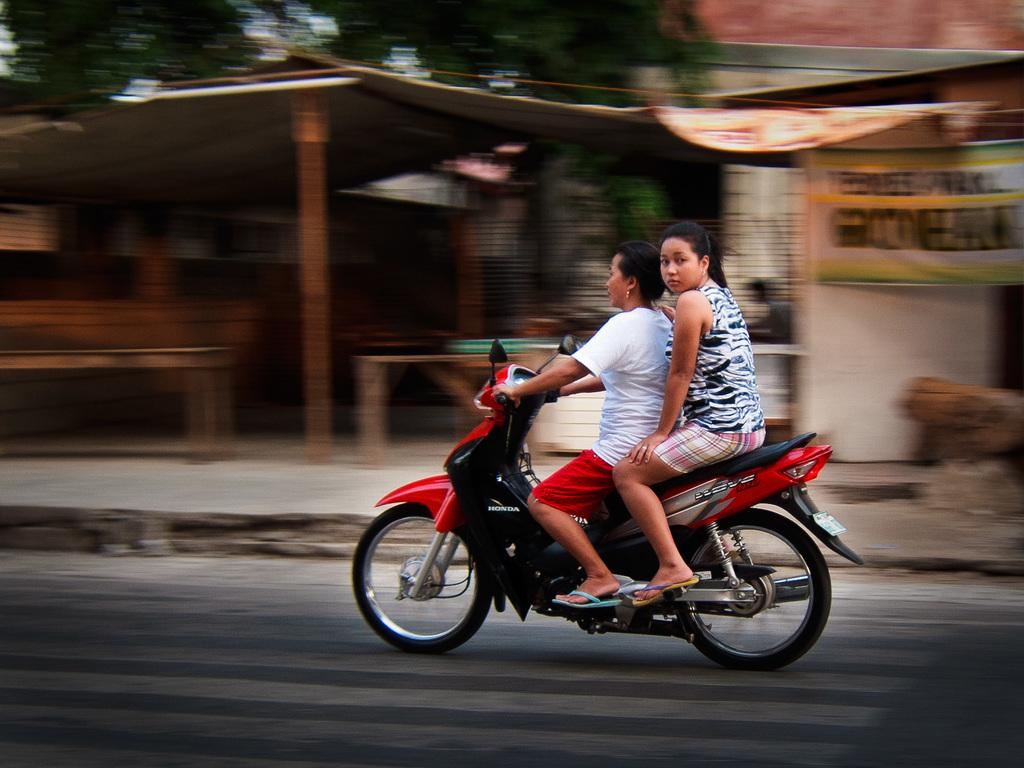How many people are in the image? There are two women in the image. What are the women doing in the image? The women are riding a bike. What can be seen in the background of the image? There is a poster attached to a building and a small house in the background. What type of tree can be seen growing in the mind of one of the women in the image? There is no tree growing in the mind of either woman in the image, as minds are not visible in the image. 